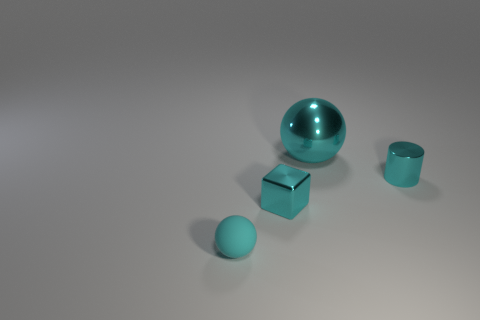Add 4 shiny cubes. How many objects exist? 8 Subtract all cubes. How many objects are left? 3 Subtract 0 gray blocks. How many objects are left? 4 Subtract all green objects. Subtract all rubber balls. How many objects are left? 3 Add 4 cyan shiny cubes. How many cyan shiny cubes are left? 5 Add 2 big red metal balls. How many big red metal balls exist? 2 